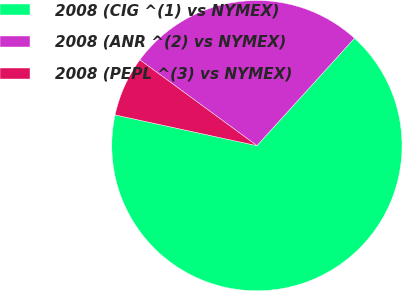Convert chart. <chart><loc_0><loc_0><loc_500><loc_500><pie_chart><fcel>2008 (CIG ^(1) vs NYMEX)<fcel>2008 (ANR ^(2) vs NYMEX)<fcel>2008 (PEPL ^(3) vs NYMEX)<nl><fcel>66.67%<fcel>26.67%<fcel>6.67%<nl></chart> 